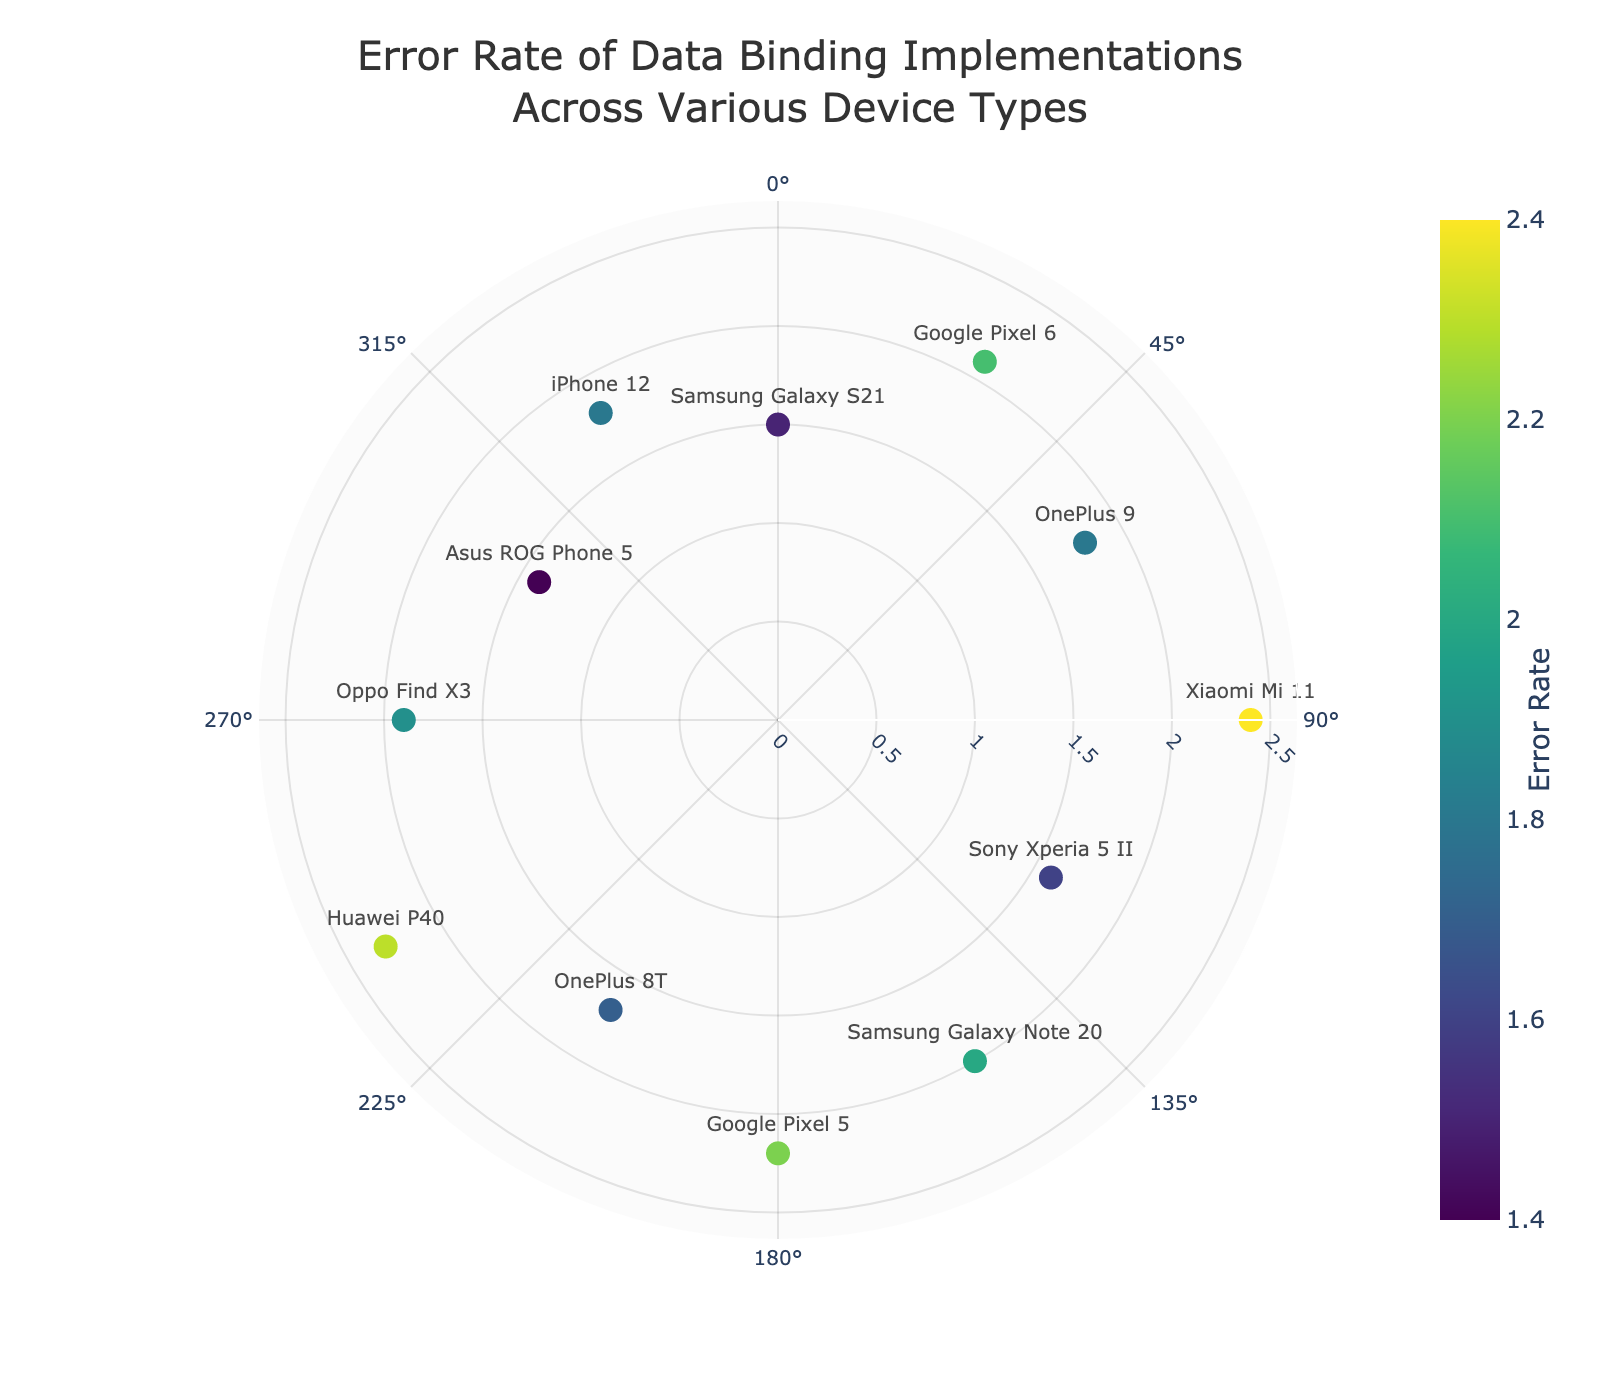What's the device type with the highest error rate? To find the device type with the highest error rate, look for the point with the largest distance from the center in the plot. The label attached to this point will provide the device type. In this case, Xiaomi Mi 11 has the highest error rate of 2.4.
Answer: Xiaomi Mi 11 What's the title of the chart? The title of the chart is displayed at the top of the figure, centered and often larger in font size. Here, it reads "Error Rate of Data Binding Implementations Across Various Device Types."
Answer: Error Rate of Data Binding Implementations Across Various Device Types Which device type has the lowest error rate? To locate the lowest error rate, identify the point closest to the center in the polar scatter plot. The label of this point reveals the device type, which is Asus ROG Phone 5 with an error rate of 1.4.
Answer: Asus ROG Phone 5 What is the average error rate across all device types? To compute the average error rate, sum all individual error rates and divide by the number of devices. Sum = 1.5 + 2.1 + 1.8 + 2.4 + 1.6 + 2.0 + 2.2 + 1.7 + 2.3 + 1.9 + 1.4 + 1.8 = 22.7. There are 12 devices. Average = 22.7 / 12 ≈ 1.89.
Answer: 1.89 Which device types have an error rate greater than 2.0? Observe the radial distances from the center and select points with distances greater than 2.0. The corresponding labels are Google Pixel 6 (2.1), Xiaomi Mi 11 (2.4), Google Pixel 5 (2.2), and Huawei P40 (2.3).
Answer: Google Pixel 6, Xiaomi Mi 11, Google Pixel 5, Huawei P40 Compare the error rates of Samsung Galaxy S21 and iPhone 12. Which one is higher? Locate the markers for Samsung Galaxy S21 and iPhone 12. Samsung Galaxy S21 has an error rate of 1.5, while iPhone 12 has an error rate of 1.8. Thus, iPhone 12 has a higher error rate.
Answer: iPhone 12 How many device types have an error rate lower than 2.0? Count the markers within the inner radial circle that corresponds to an error rate of 2.0. The devices are Samsung Galaxy S21, OnePlus 9, Sony Xperia 5 II, OnePlus 8T, Oppo Find X3, Asus ROG Phone 5, and iPhone 12. Total = 7.
Answer: 7 What is the error rate for OnePlus 9, and at what angle is it positioned? Locate OnePlus 9's label on the plot. Its radial distance, representing the error rate, is 1.8, and its angular position is 60 degrees.
Answer: 1.8, 60 degrees What color is used for the marker with the highest error rate, and what does the color represent? The color scale represents the error rate, with different shades indicating varying error rates. Locate the color bar for reference. Xiaomi Mi 11 has the highest error rate at 2.4, reflected by a darker shade on the Viridis scale.
Answer: Darker shade, represents higher error rate 